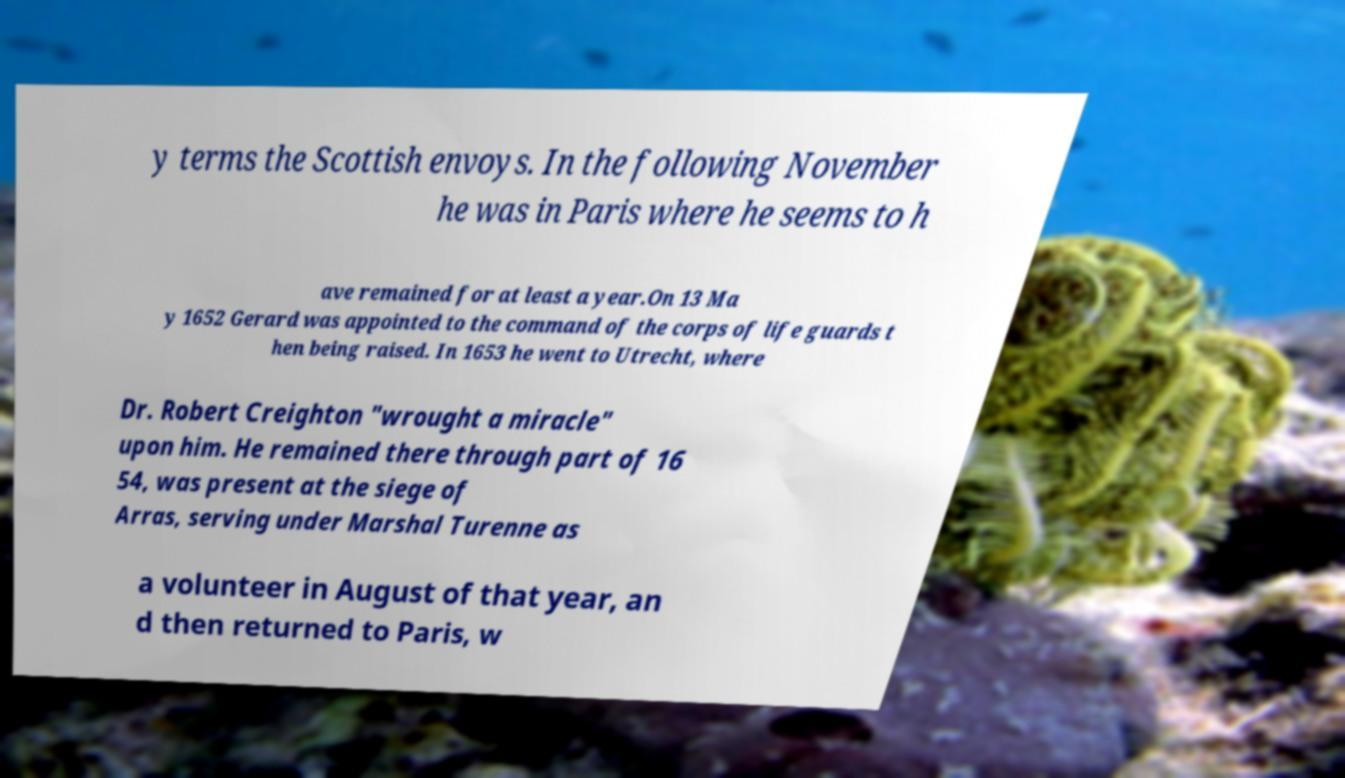Please identify and transcribe the text found in this image. y terms the Scottish envoys. In the following November he was in Paris where he seems to h ave remained for at least a year.On 13 Ma y 1652 Gerard was appointed to the command of the corps of life guards t hen being raised. In 1653 he went to Utrecht, where Dr. Robert Creighton "wrought a miracle" upon him. He remained there through part of 16 54, was present at the siege of Arras, serving under Marshal Turenne as a volunteer in August of that year, an d then returned to Paris, w 